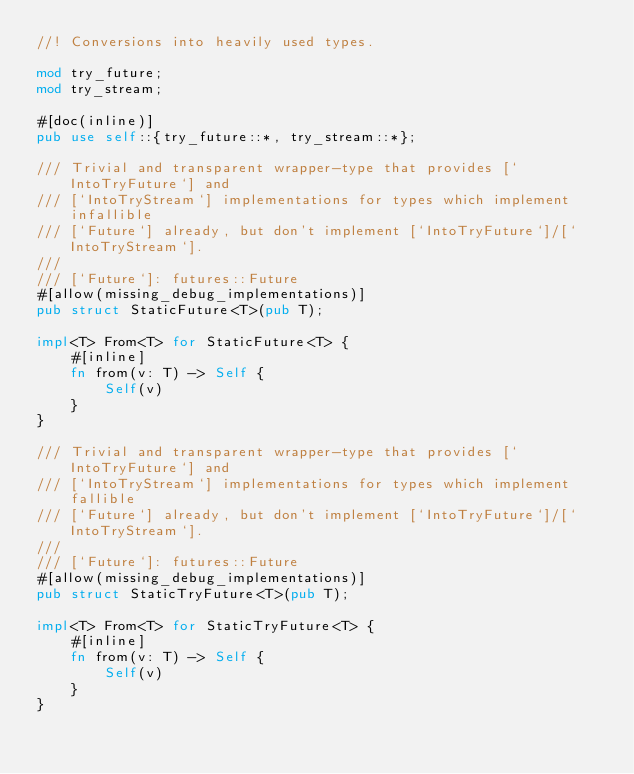<code> <loc_0><loc_0><loc_500><loc_500><_Rust_>//! Conversions into heavily used types.

mod try_future;
mod try_stream;

#[doc(inline)]
pub use self::{try_future::*, try_stream::*};

/// Trivial and transparent wrapper-type that provides [`IntoTryFuture`] and
/// [`IntoTryStream`] implementations for types which implement infallible
/// [`Future`] already, but don't implement [`IntoTryFuture`]/[`IntoTryStream`].
///
/// [`Future`]: futures::Future
#[allow(missing_debug_implementations)]
pub struct StaticFuture<T>(pub T);

impl<T> From<T> for StaticFuture<T> {
    #[inline]
    fn from(v: T) -> Self {
        Self(v)
    }
}

/// Trivial and transparent wrapper-type that provides [`IntoTryFuture`] and
/// [`IntoTryStream`] implementations for types which implement fallible
/// [`Future`] already, but don't implement [`IntoTryFuture`]/[`IntoTryStream`].
///
/// [`Future`]: futures::Future
#[allow(missing_debug_implementations)]
pub struct StaticTryFuture<T>(pub T);

impl<T> From<T> for StaticTryFuture<T> {
    #[inline]
    fn from(v: T) -> Self {
        Self(v)
    }
}
</code> 